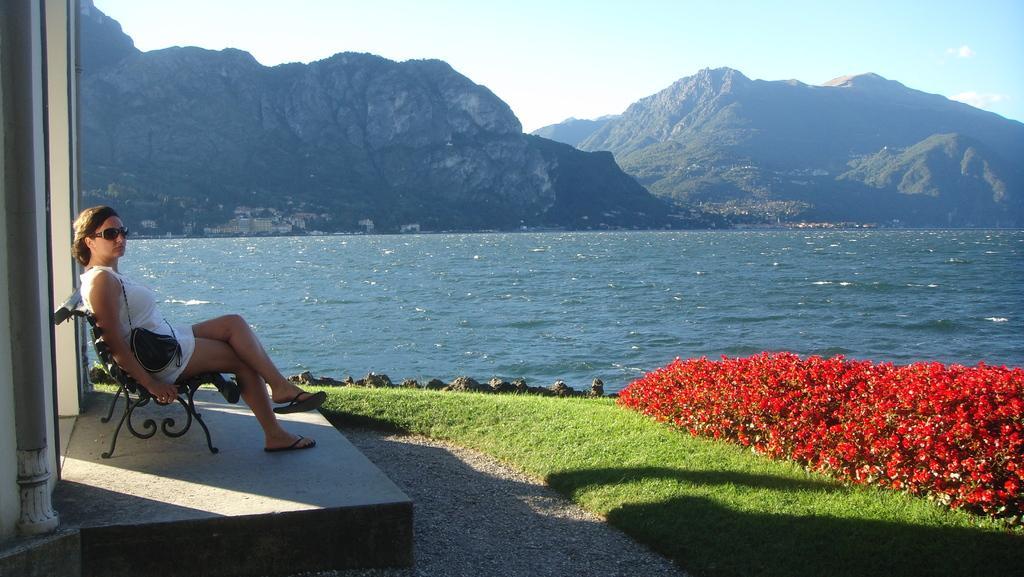Please provide a concise description of this image. In this picture I can see a person sitting on the bench, there are flowers, there is grass, there is water, there are mountains, and in the background there is the sky. 